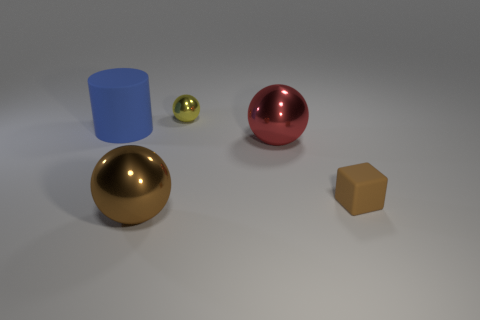What number of objects have the same color as the small rubber block?
Provide a short and direct response. 1. There is another object that is the same color as the small rubber thing; what is its material?
Your answer should be compact. Metal. Are there an equal number of brown rubber things that are behind the tiny rubber cube and green rubber cylinders?
Your answer should be compact. Yes. There is a matte object in front of the red metal ball; is its size the same as the small shiny object?
Provide a short and direct response. Yes. How many large purple matte objects are there?
Your answer should be compact. 0. What number of things are left of the small brown matte thing and in front of the large red metal object?
Offer a very short reply. 1. Is there a large gray ball that has the same material as the tiny brown block?
Provide a succinct answer. No. There is a large thing right of the large ball on the left side of the red sphere; what is its material?
Offer a terse response. Metal. Are there the same number of red shiny spheres behind the small shiny ball and big metallic spheres that are behind the brown sphere?
Your answer should be very brief. No. Do the large red shiny thing and the small yellow metallic object have the same shape?
Ensure brevity in your answer.  Yes. 